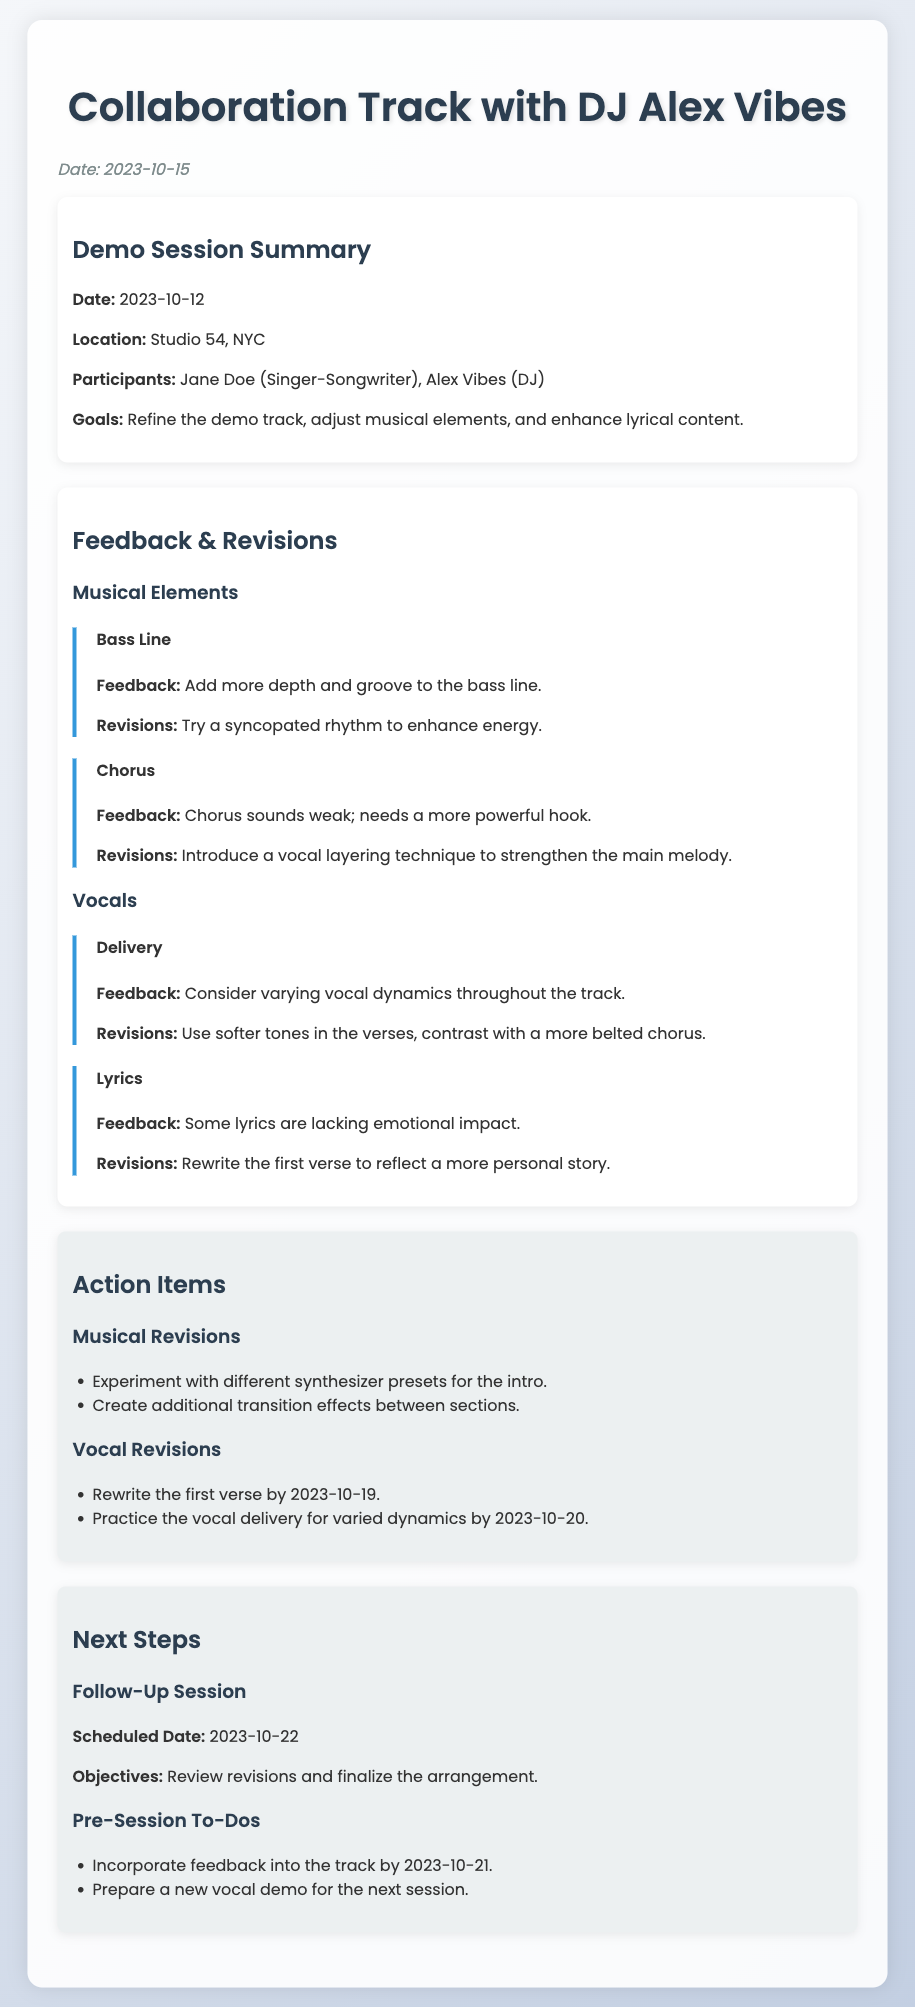What is the date of the demo session? The date of the demo session is mentioned in the document as 2023-10-12.
Answer: 2023-10-12 Who is the DJ collaborating with the singer-songwriter? The document states that the DJ collaborating is Alex Vibes.
Answer: Alex Vibes What two elements are suggested to be revised in the bass line? The feedback for the bass line mentions adding more depth and groove.
Answer: Depth and groove What is the scheduled date for the follow-up session? The follow-up session is scheduled for 2023-10-22 according to the document.
Answer: 2023-10-22 By when is the first verse supposed to be rewritten? The document specifies that the first verse should be rewritten by 2023-10-19.
Answer: 2023-10-19 What location was used for the demo session? The document mentions that the demo session took place at Studio 54, NYC.
Answer: Studio 54, NYC What is one of the objectives for the next session? The objective for the next session is to review revisions and finalize the arrangement.
Answer: Review revisions and finalize the arrangement What are the two types of revisions listed in the action items? The action items include musical revisions and vocal revisions.
Answer: Musical and vocal revisions What feedback was given about the chorus? The feedback states that the chorus sounds weak and needs a more powerful hook.
Answer: Sounds weak; needs a more powerful hook 